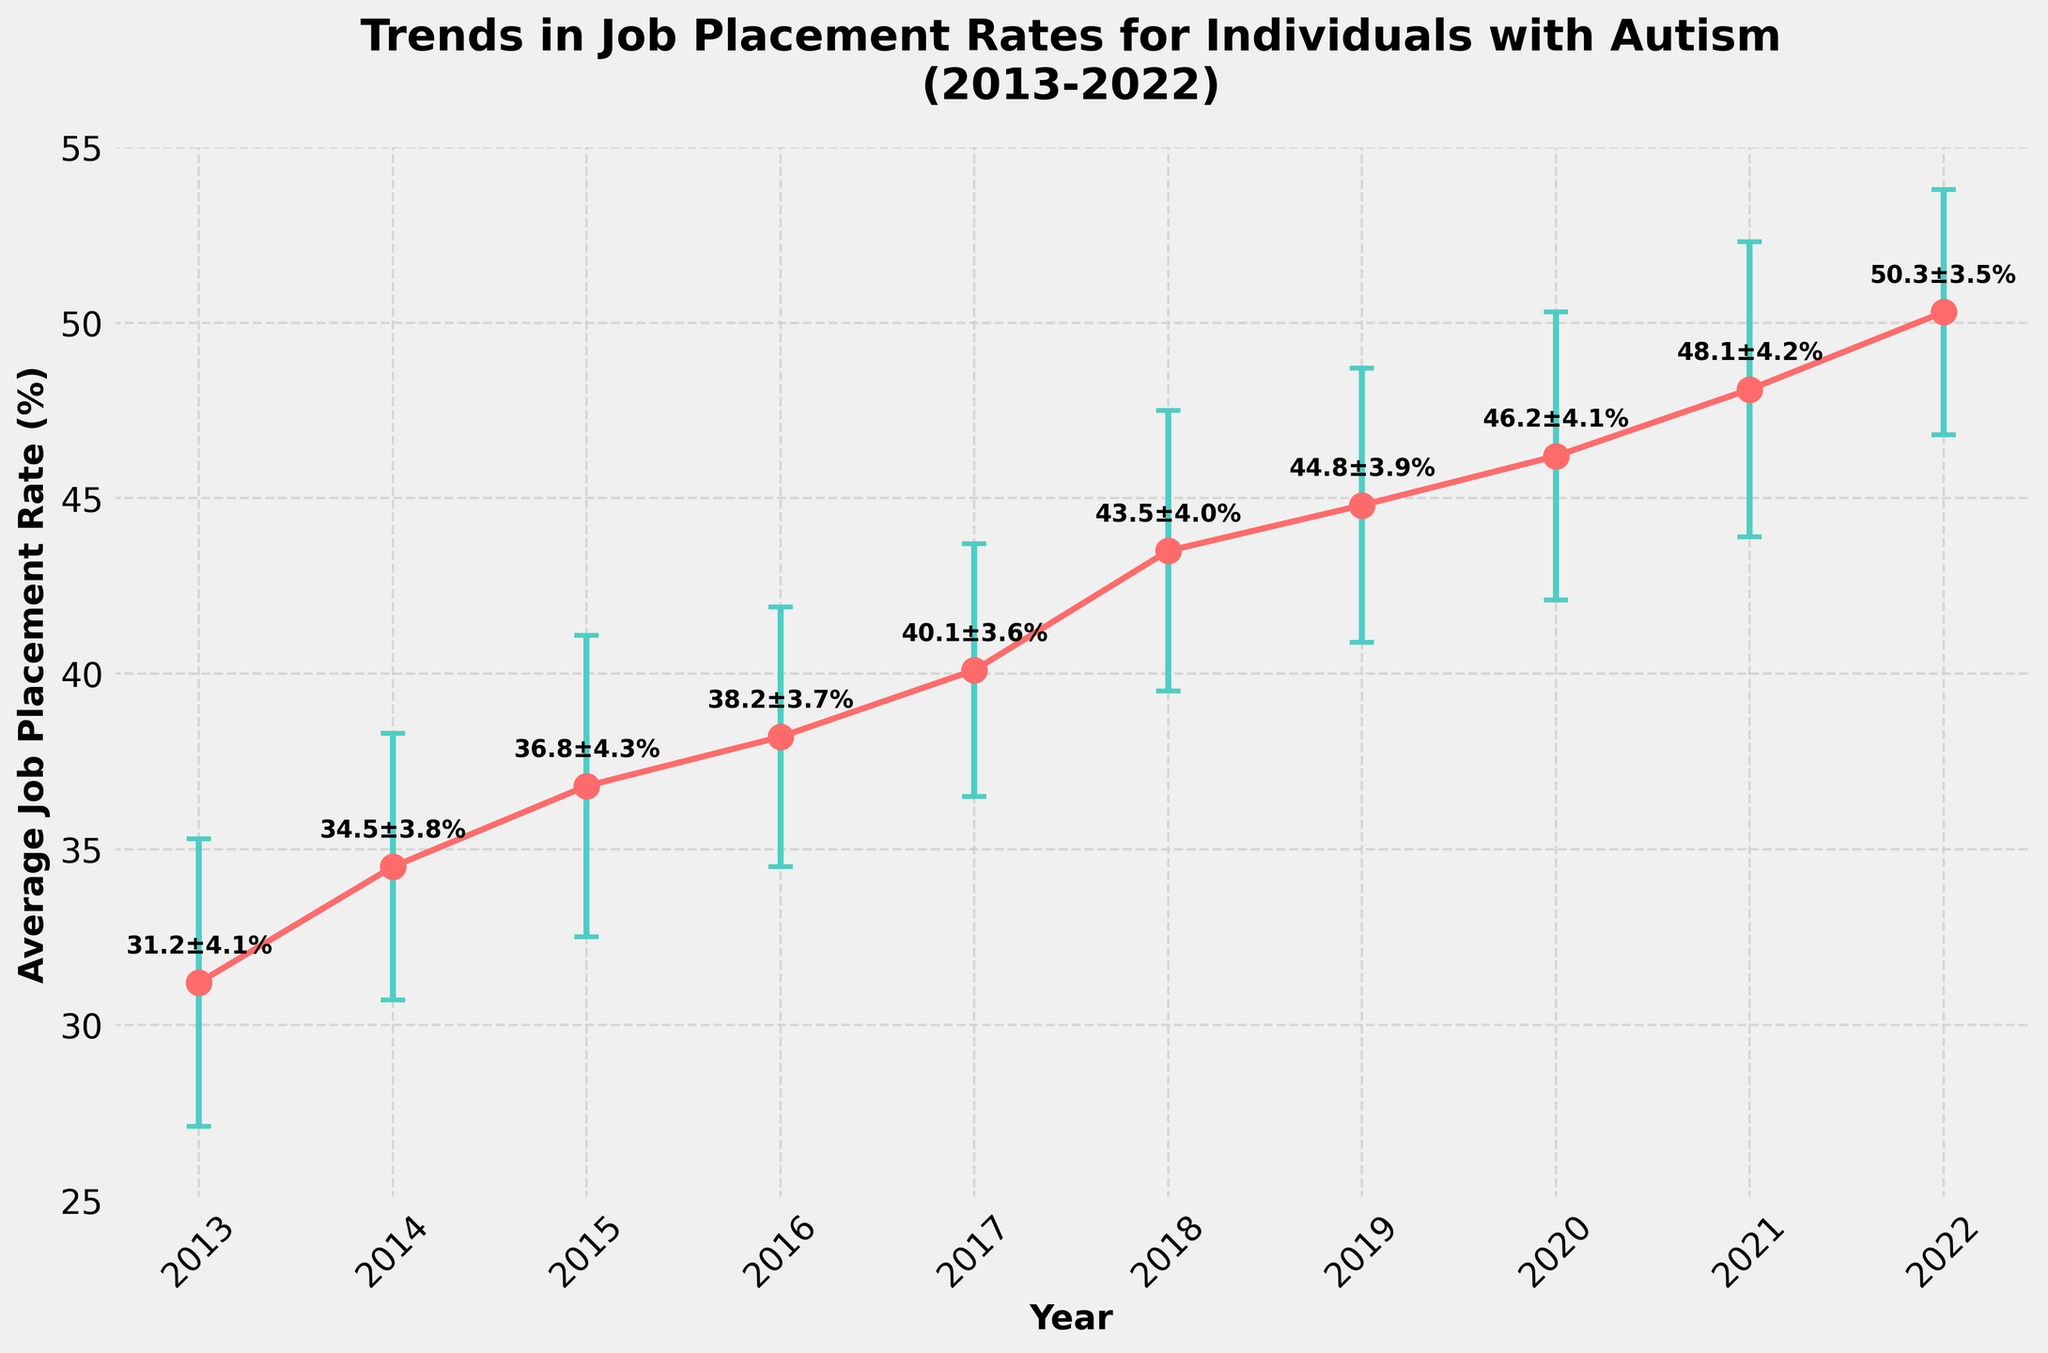What's the overall trend in the job placement rates for individuals with autism over the past decade? The line plot shows a general upward trend in the average job placement rates from 2013 to 2022. This means that the average job placement rate has increased over the years.
Answer: Upward trend What is the average job placement rate in 2022? The figure shows each data point labeled with its corresponding value, and the data point for 2022 is marked. The label indicates the average job placement rate.
Answer: 50.3% Which year had the lowest job placement rate? By observing the lowest data point on the line plot and checking its corresponding label, we see that 2013 has the lowest rate.
Answer: 2013 How much did the average job placement rate change from 2013 to 2022? Start by finding the values for 2013 and 2022 from the figure. Subtract the 2013 value (31.2%) from the 2022 value (50.3%).
Answer: 19.1% What year had the highest annual variation (standard deviation) in job placement rates? By identifying the year with the largest error bar (standard deviation) in the plot, we see 2015 has the highest variability with an error of ±4.3%.
Answer: 2015 Compare the job placement rates between 2017 and 2020. Which year had a higher rate? By comparing the labeled data points for 2017 (40.1%) and 2020 (46.2%), we see that 2020 had a higher rate.
Answer: 2020 What is the range of the job placement rates over the decade? The range is calculated by subtracting the smallest rate (2013: 31.2%) from the largest rate (2022: 50.3%).
Answer: 19.1% Are there any years where the job placement rate did not increase from the previous year? By observing the consecutive data points in the plot, it is noticeable that every year shows an increase from the preceding year.
Answer: No What is the average annual increase in job placement rates from 2013 to 2022? Calculate the total change in job placement rate (50.3% - 31.2% = 19.1%) and divide it by the number of intervals (2022 - 2013 = 9 years).
Answer: ≈2.12% During which year did job placement rates increase the most compared to the previous year? By comparing year-over-year increases, the largest increase is from 2017 to 2018 (43.5% - 40.1% = 3.4%).
Answer: 2018 